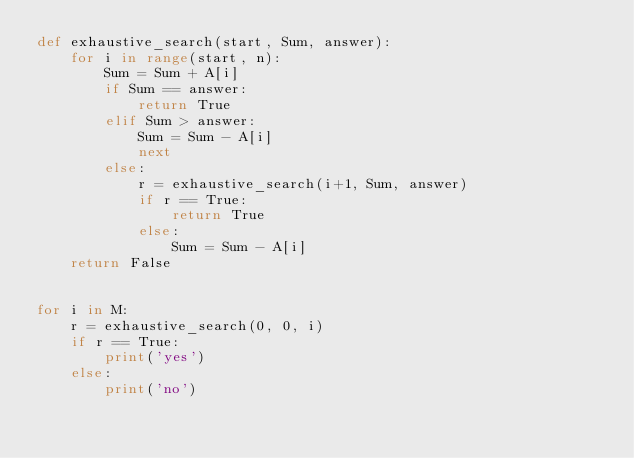Convert code to text. <code><loc_0><loc_0><loc_500><loc_500><_Python_>def exhaustive_search(start, Sum, answer):
    for i in range(start, n):
        Sum = Sum + A[i]
        if Sum == answer:
            return True
        elif Sum > answer:
            Sum = Sum - A[i]
            next
        else:
            r = exhaustive_search(i+1, Sum, answer)
            if r == True:
                return True
            else:
                Sum = Sum - A[i]
    return False


for i in M:
    r = exhaustive_search(0, 0, i)
    if r == True:
        print('yes')
    else:
        print('no')</code> 